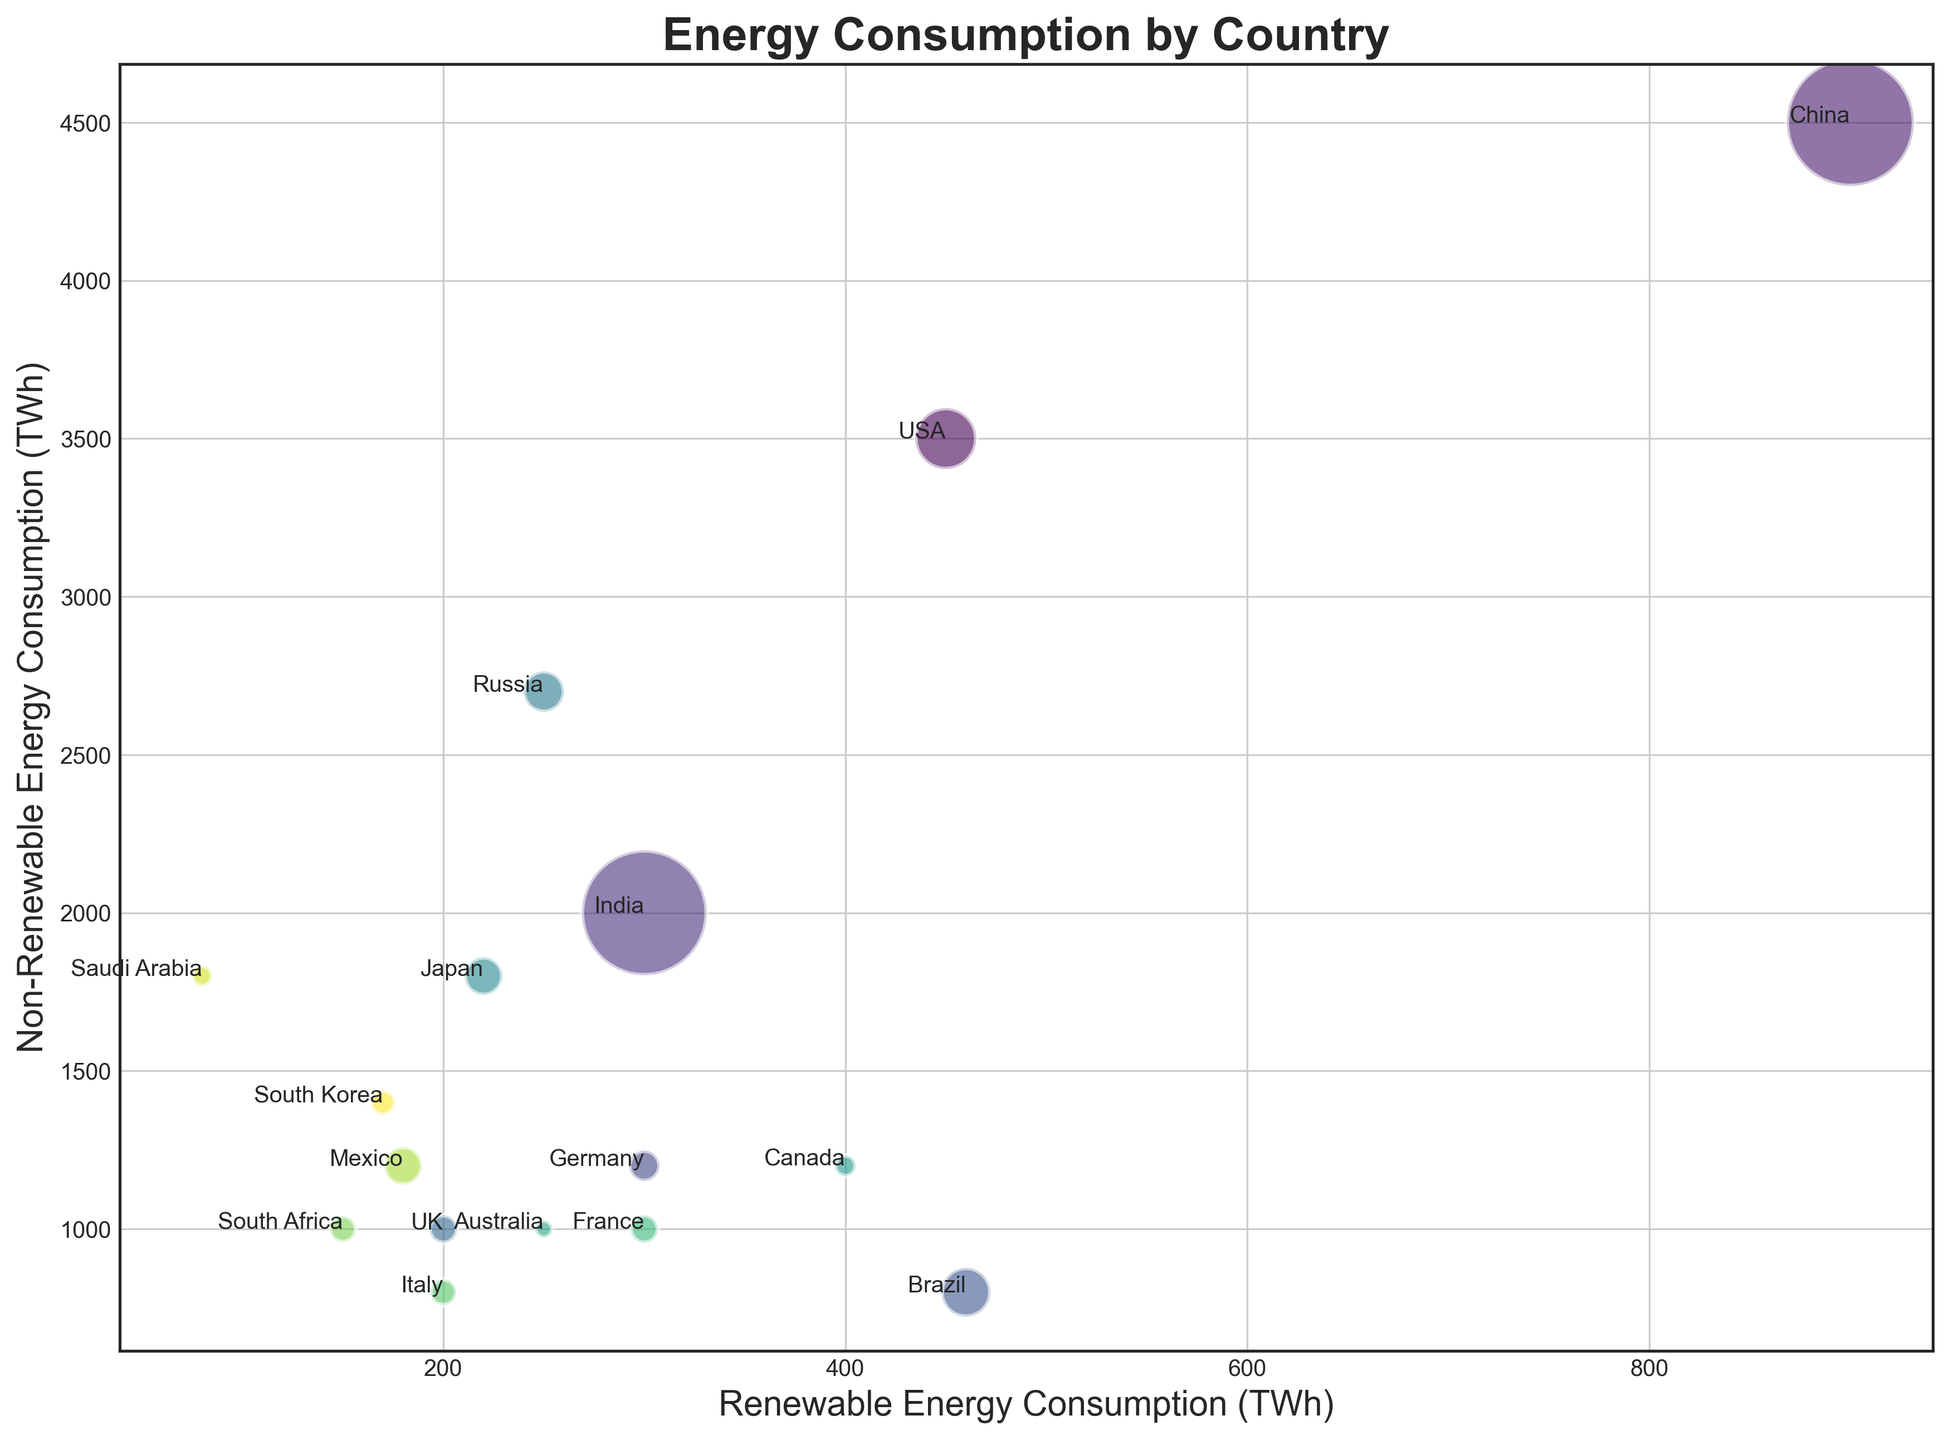Which country has the highest consumption of renewable energy? The highest point on the renewable energy axis (X-axis) corresponds to China, which consumes 900 TWh of renewable energy.
Answer: China Which country consumes more non-renewable energy, the USA or Russia? Comparing the non-renewable energy consumption (Y-axis) of both countries, the USA (3500 TWh) consumes more non-renewable energy than Russia (2700 TWh).
Answer: USA What is the overall energy consumption (renewable + non-renewable) for Germany? Summing up Germany's renewable (300 TWh) and non-renewable energy consumption (1200 TWh) gives a total of 300 + 1200 = 1500 TWh.
Answer: 1500 TWh Which country has the smallest bubble on the chart, indicating the smallest population size? The smallest bubble visually corresponds to Australia, indicating it has the smallest population among the listed countries.
Answer: Australia Between France and Italy, which country has higher renewable energy consumption? Comparing the positions on the X-axis, France (300 TWh) has higher renewable energy consumption than Italy (200 TWh).
Answer: France What is the ratio of renewable to non-renewable energy consumption in Brazil? The renewable energy consumption in Brazil is 460 TWh and non-renewable is 800 TWh. The ratio is calculated as 460/800 = 0.575.
Answer: 0.575 Which countries have a higher proportion of renewable energy consumption to non-renewable energy consumption than the USA? Calculate the ratio for the USA: 450/3500 = 0.129. Countries like Brazil (460/800 = 0.575), Canada (400/1200 = 0.333), Germany (300/1200 = 0.25), and several others have higher proportions.
Answer: Brazil, Canada, Germany, etc How does the bubble size of India compare to the bubble size of the UK? Visually, India's bubble is much larger than the UK's bubble, reflecting India's significantly larger population.
Answer: Larger What is the average renewable energy consumption of the listed countries? Sum of all renewable energy consumption = 450+900+300+300+460+200+250+220+400+250+300+200+150+180+80+170 = 4810 TWh. The number of countries is 16. The average is 4810/16 = 300.625 TWh.
Answer: 300.625 TWh 